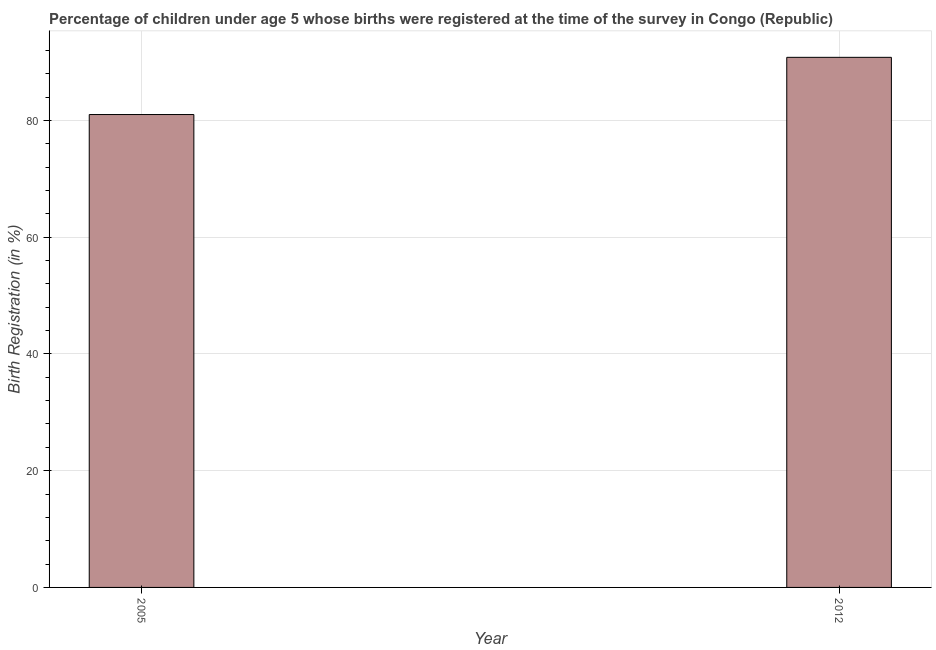Does the graph contain any zero values?
Your answer should be compact. No. What is the title of the graph?
Provide a succinct answer. Percentage of children under age 5 whose births were registered at the time of the survey in Congo (Republic). What is the label or title of the Y-axis?
Ensure brevity in your answer.  Birth Registration (in %). Across all years, what is the maximum birth registration?
Make the answer very short. 90.8. Across all years, what is the minimum birth registration?
Ensure brevity in your answer.  81. In which year was the birth registration maximum?
Your response must be concise. 2012. What is the sum of the birth registration?
Give a very brief answer. 171.8. What is the difference between the birth registration in 2005 and 2012?
Offer a very short reply. -9.8. What is the average birth registration per year?
Offer a terse response. 85.9. What is the median birth registration?
Your response must be concise. 85.9. In how many years, is the birth registration greater than 24 %?
Your response must be concise. 2. What is the ratio of the birth registration in 2005 to that in 2012?
Ensure brevity in your answer.  0.89. Is the birth registration in 2005 less than that in 2012?
Make the answer very short. Yes. In how many years, is the birth registration greater than the average birth registration taken over all years?
Make the answer very short. 1. What is the Birth Registration (in %) in 2012?
Your response must be concise. 90.8. What is the difference between the Birth Registration (in %) in 2005 and 2012?
Offer a terse response. -9.8. What is the ratio of the Birth Registration (in %) in 2005 to that in 2012?
Provide a succinct answer. 0.89. 